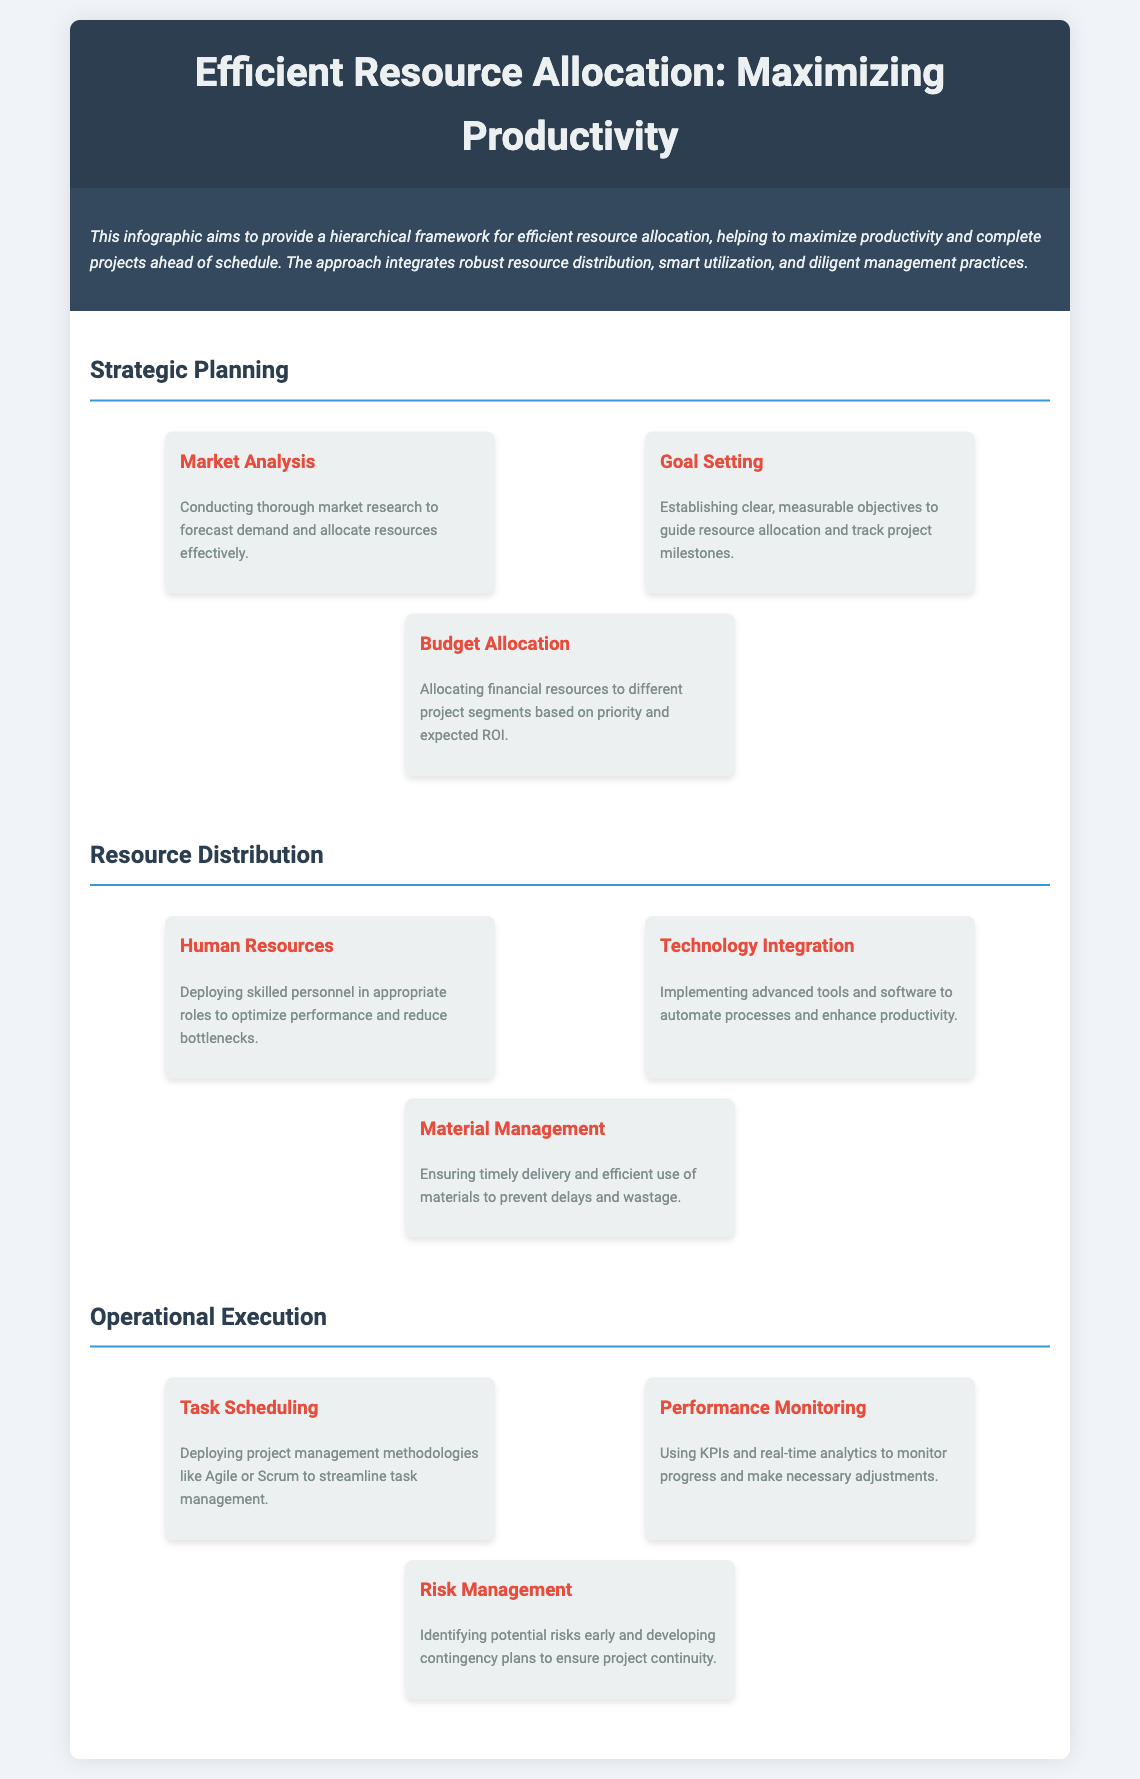What is the title of the document? The title is prominently displayed at the top of the document and is "Efficient Resource Allocation: Maximizing Productivity."
Answer: Efficient Resource Allocation: Maximizing Productivity How many elements are listed under "Resource Distribution"? The section titled "Resource Distribution" contains three elements listed below it.
Answer: 3 What methodology is suggested for task management? The document indicates using project management methodologies like Agile or Scrum for task management.
Answer: Agile or Scrum What is one purpose of market analysis? The document states that market analysis helps in forecasting demand and allocating resources effectively.
Answer: Forecasting demand What is a key component of performance monitoring? The document mentions using KPIs and real-time analytics as key components in monitoring performance.
Answer: KPIs and real-time analytics Which level includes "Risk Management"? The "Risk Management" element is part of the "Operational Execution" level in the hierarchy.
Answer: Operational Execution What is a goal of budget allocation? The document specifies that the goal of budget allocation is to prioritize project segments based on expected ROI.
Answer: Expected ROI What is the background color of the document's header? The header has a specific color defined in the style section of the document, which is a dark color.
Answer: Dark color 